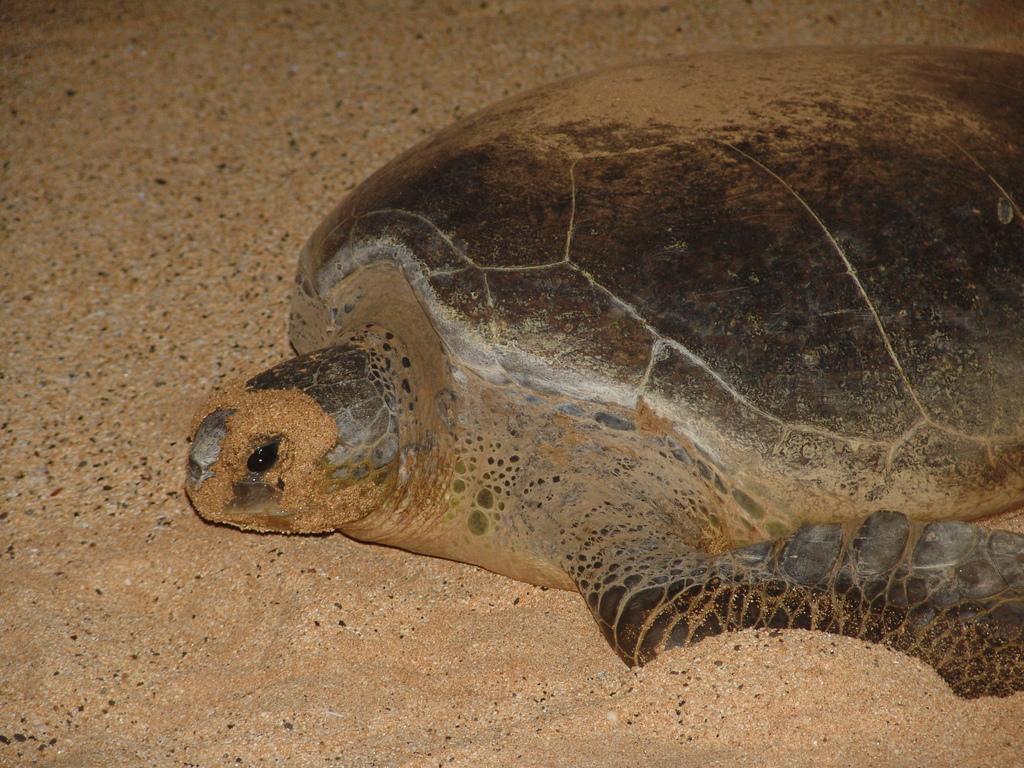In one or two sentences, can you explain what this image depicts? This picture contains a turtle which is in brown and black color. At the bottom of the picture, we see rock and this picture might be clicked in a zoo. 